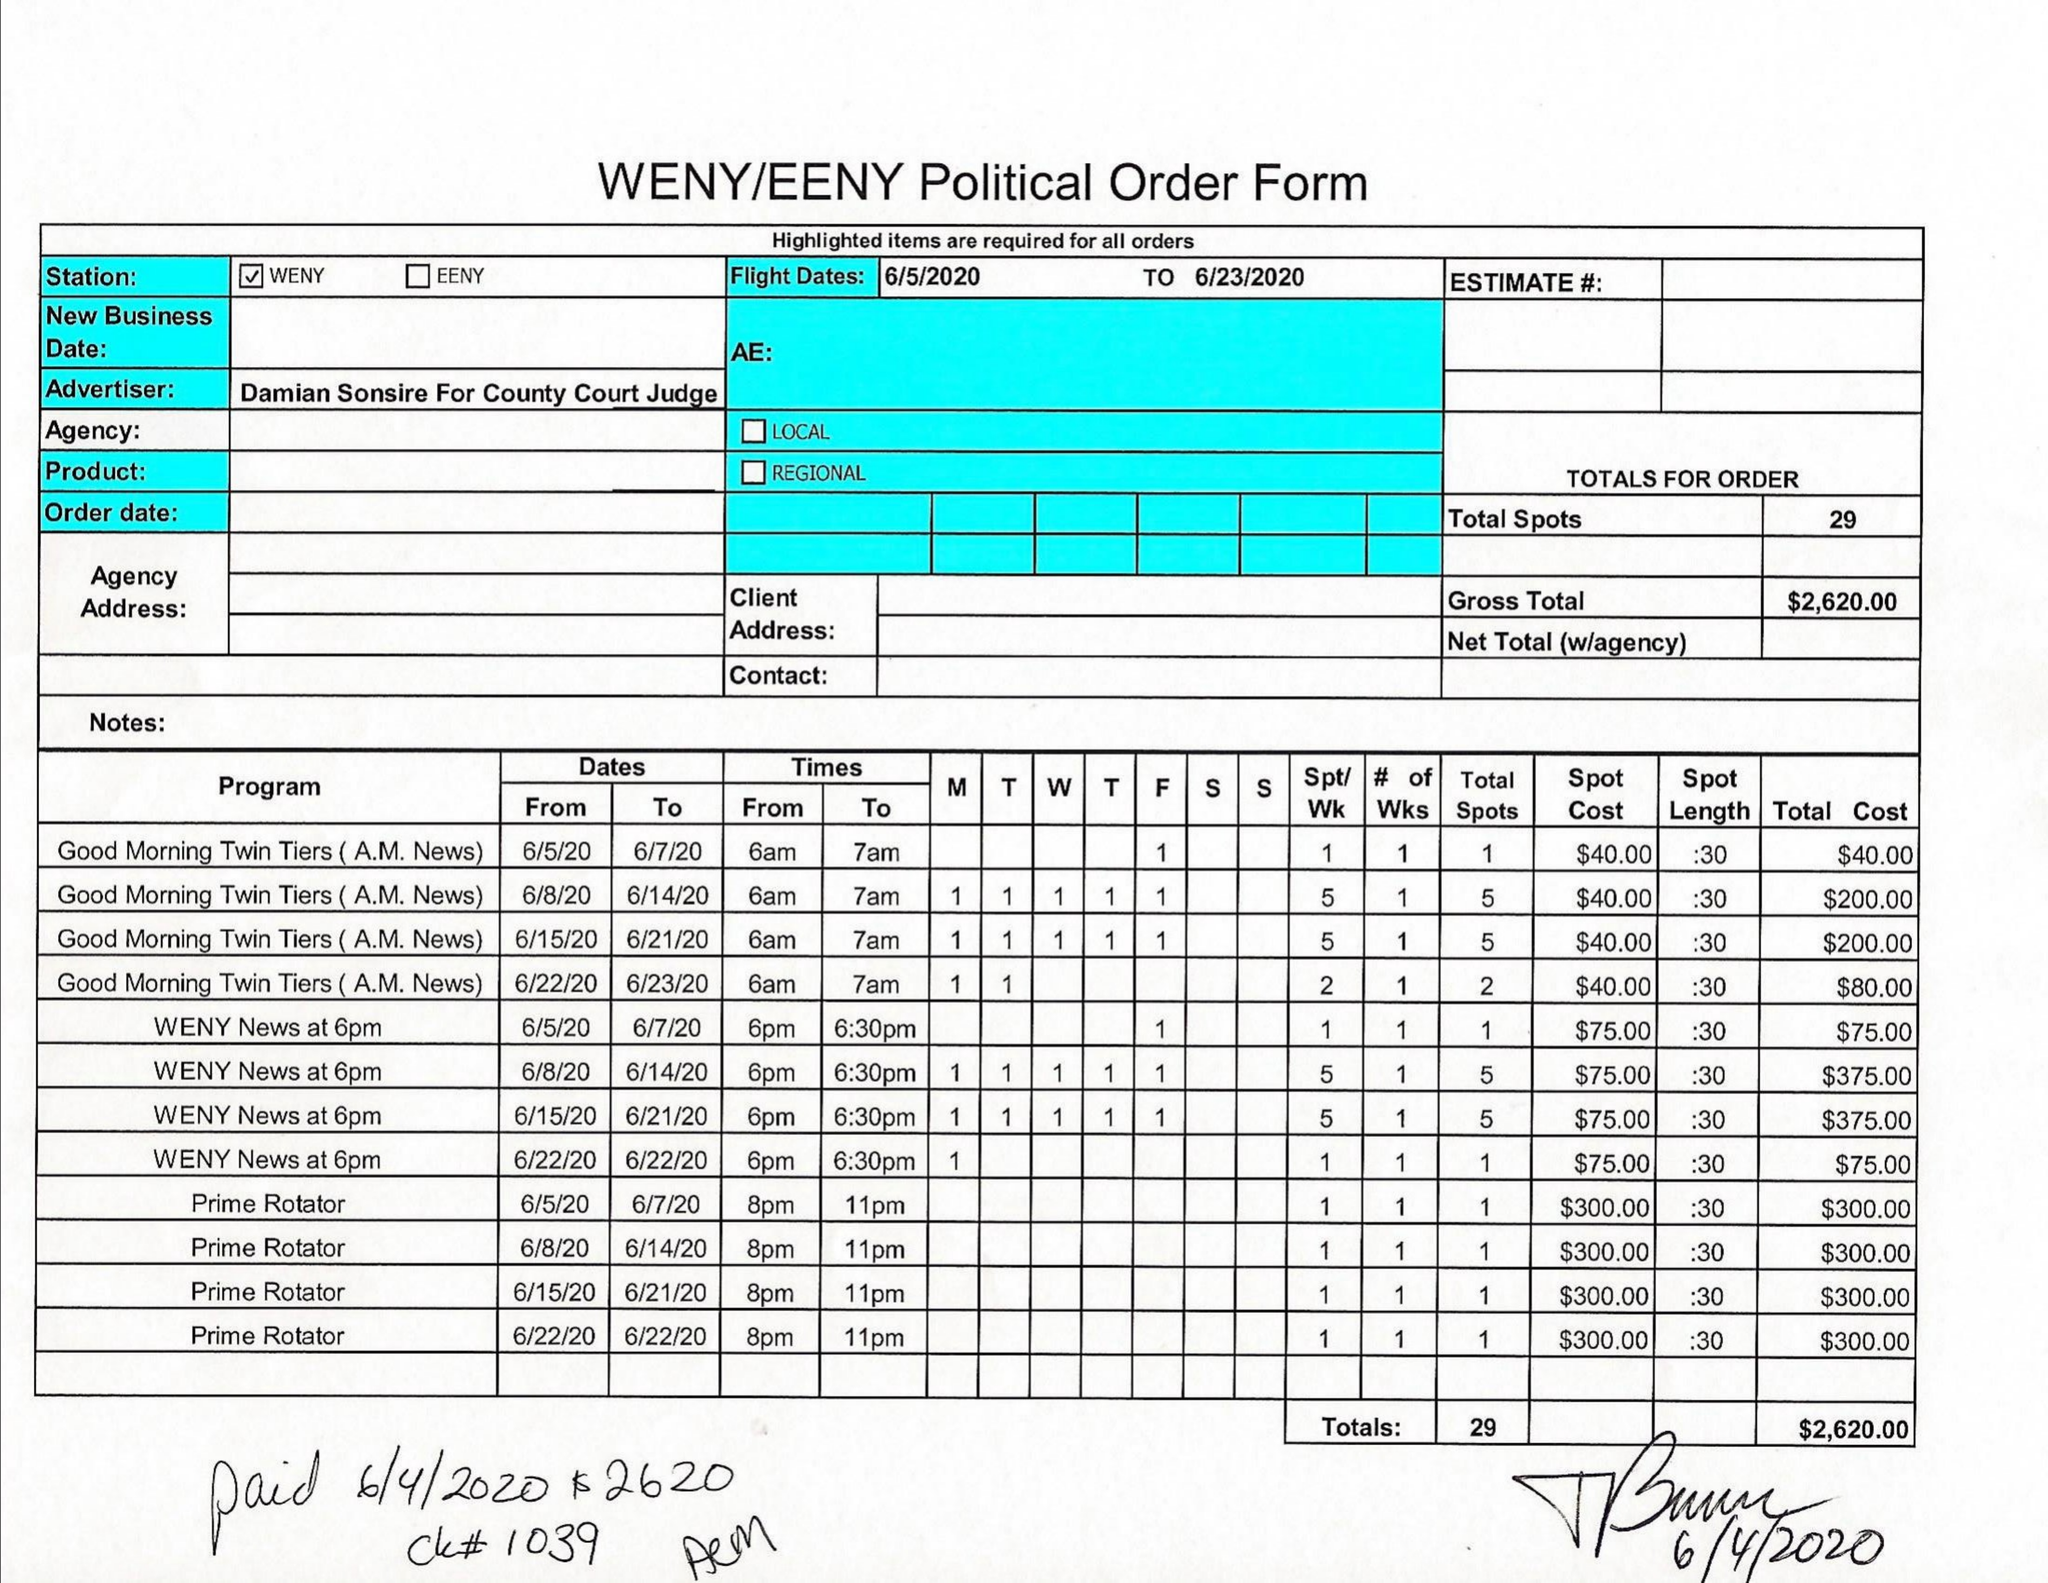What is the value for the contract_num?
Answer the question using a single word or phrase. None 